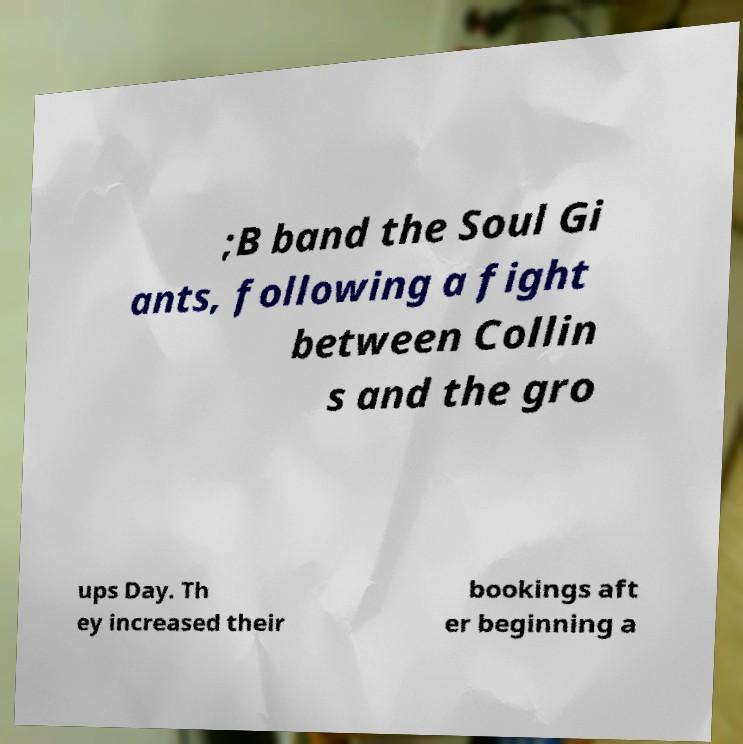There's text embedded in this image that I need extracted. Can you transcribe it verbatim? ;B band the Soul Gi ants, following a fight between Collin s and the gro ups Day. Th ey increased their bookings aft er beginning a 